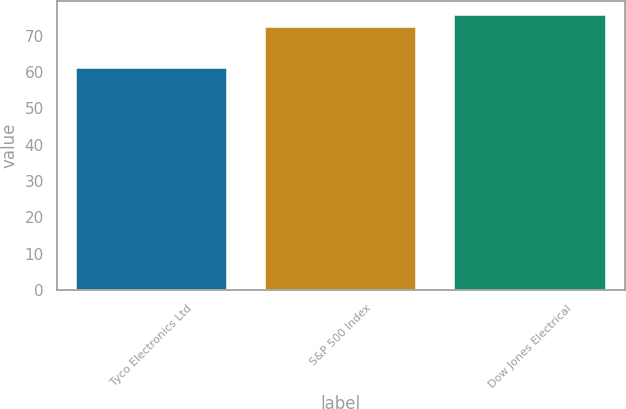Convert chart to OTSL. <chart><loc_0><loc_0><loc_500><loc_500><bar_chart><fcel>Tyco Electronics Ltd<fcel>S&P 500 Index<fcel>Dow Jones Electrical<nl><fcel>61.15<fcel>72.29<fcel>75.74<nl></chart> 